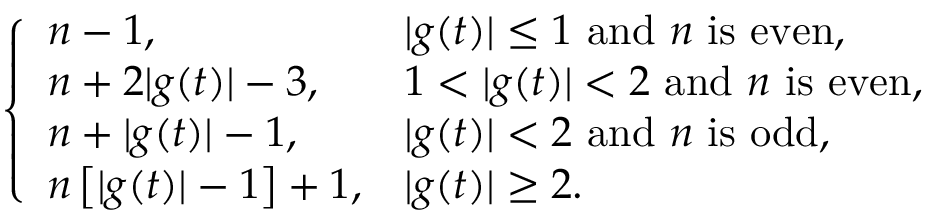Convert formula to latex. <formula><loc_0><loc_0><loc_500><loc_500>\left \{ \begin{array} { l l } { n - 1 , } & { | g ( t ) | \leq 1 a n d n i s e v e n , } \\ { n + 2 | g ( t ) | - 3 , } & { 1 < | g ( t ) | < 2 a n d n i s e v e n , } \\ { n + | g ( t ) | - 1 , } & { | g ( t ) | < 2 a n d n i s o d d , } \\ { n \left [ | g ( t ) | - 1 \right ] + 1 , } & { | g ( t ) | \geq 2 . } \end{array}</formula> 